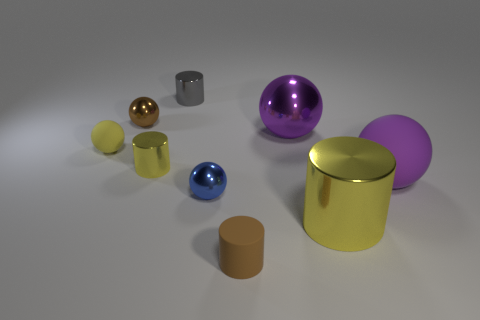There is a rubber thing that is behind the yellow metal thing behind the small ball to the right of the brown shiny thing; what color is it?
Give a very brief answer. Yellow. There is a brown sphere; is its size the same as the yellow metal thing that is on the left side of the small gray shiny thing?
Provide a succinct answer. Yes. How many things are either shiny cylinders that are to the left of the tiny blue metal thing or small metal things that are behind the big shiny ball?
Provide a succinct answer. 3. There is a yellow metal object that is the same size as the blue object; what shape is it?
Ensure brevity in your answer.  Cylinder. There is a large purple object on the right side of the purple shiny ball behind the yellow metallic cylinder that is on the right side of the large purple shiny sphere; what shape is it?
Your response must be concise. Sphere. Are there the same number of brown cylinders behind the gray metal thing and brown metallic spheres?
Give a very brief answer. No. Is the size of the blue shiny thing the same as the brown cylinder?
Your response must be concise. Yes. What number of rubber things are red cylinders or small brown balls?
Offer a terse response. 0. What material is the yellow sphere that is the same size as the gray object?
Make the answer very short. Rubber. How many other things are the same material as the tiny blue sphere?
Give a very brief answer. 5. 